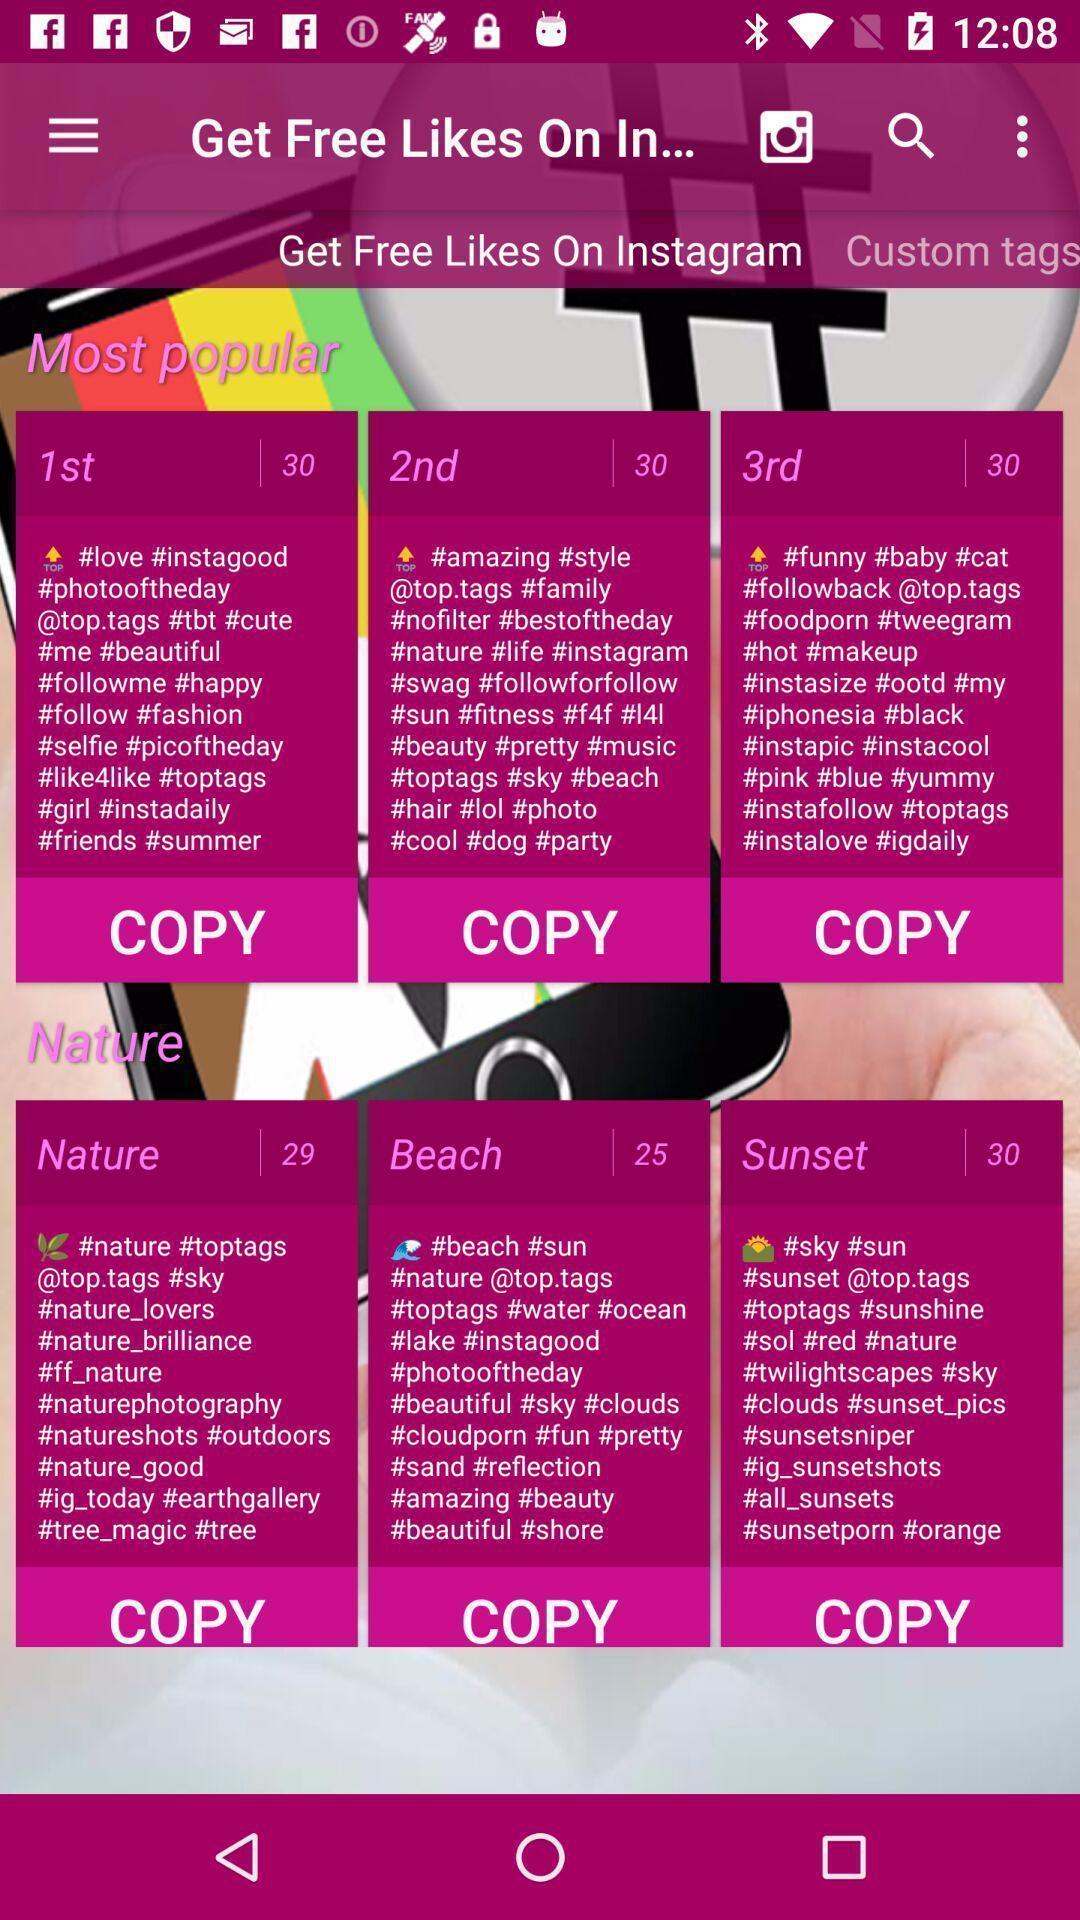What details can you identify in this image? Screen displaying the list of multiple information. 